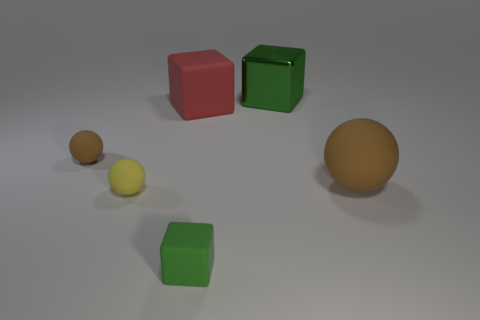Is there a blue metallic object?
Give a very brief answer. No. Is the size of the matte block that is behind the yellow matte object the same as the green object in front of the red cube?
Provide a succinct answer. No. What is the cube that is both on the right side of the big red matte object and behind the tiny matte cube made of?
Offer a very short reply. Metal. There is a yellow rubber sphere; how many green things are behind it?
Your answer should be compact. 1. There is a large block that is made of the same material as the big brown ball; what color is it?
Your response must be concise. Red. Is the shape of the big brown matte object the same as the small brown matte thing?
Provide a succinct answer. Yes. How many green blocks are both in front of the red object and behind the red object?
Keep it short and to the point. 0. How many matte things are either tiny balls or green cubes?
Provide a succinct answer. 3. How big is the green thing behind the brown rubber object left of the small yellow rubber thing?
Your answer should be compact. Large. What material is the large thing that is the same color as the tiny cube?
Ensure brevity in your answer.  Metal. 